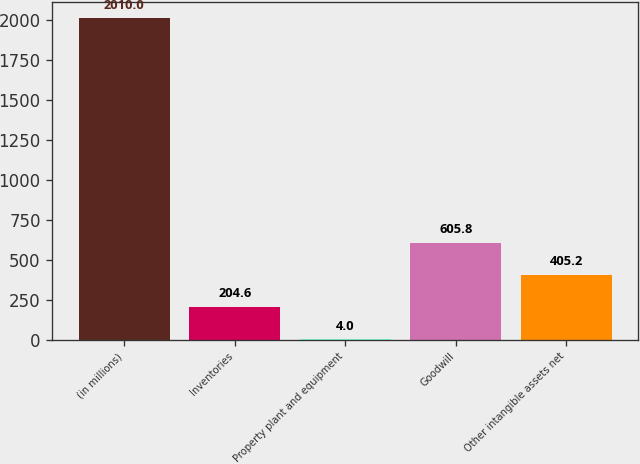Convert chart. <chart><loc_0><loc_0><loc_500><loc_500><bar_chart><fcel>(in millions)<fcel>Inventories<fcel>Property plant and equipment<fcel>Goodwill<fcel>Other intangible assets net<nl><fcel>2010<fcel>204.6<fcel>4<fcel>605.8<fcel>405.2<nl></chart> 